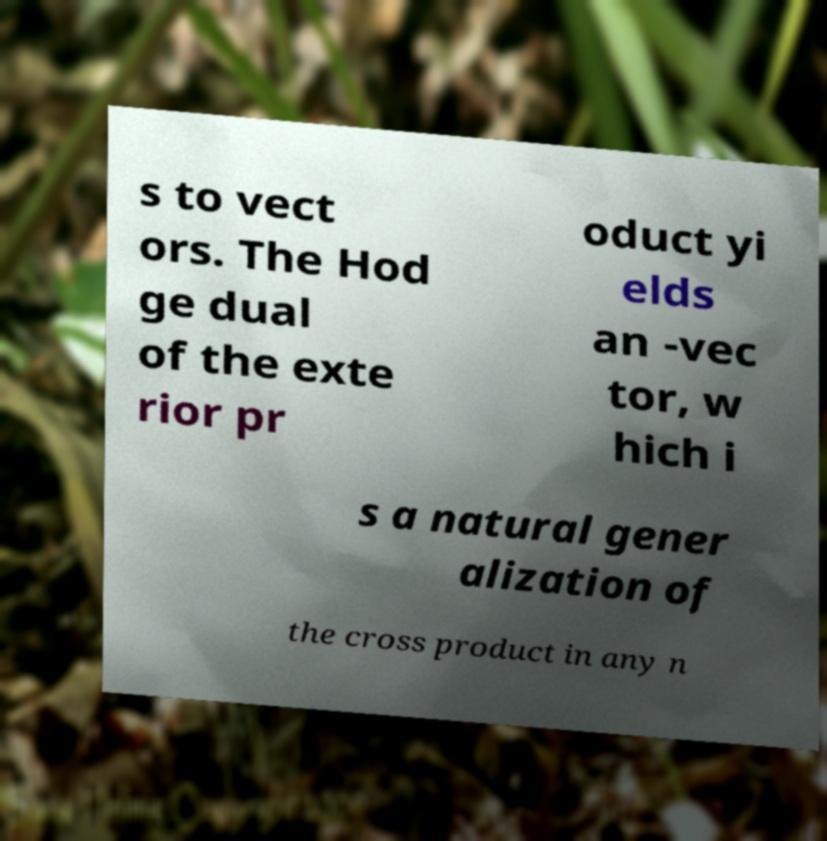What messages or text are displayed in this image? I need them in a readable, typed format. s to vect ors. The Hod ge dual of the exte rior pr oduct yi elds an -vec tor, w hich i s a natural gener alization of the cross product in any n 